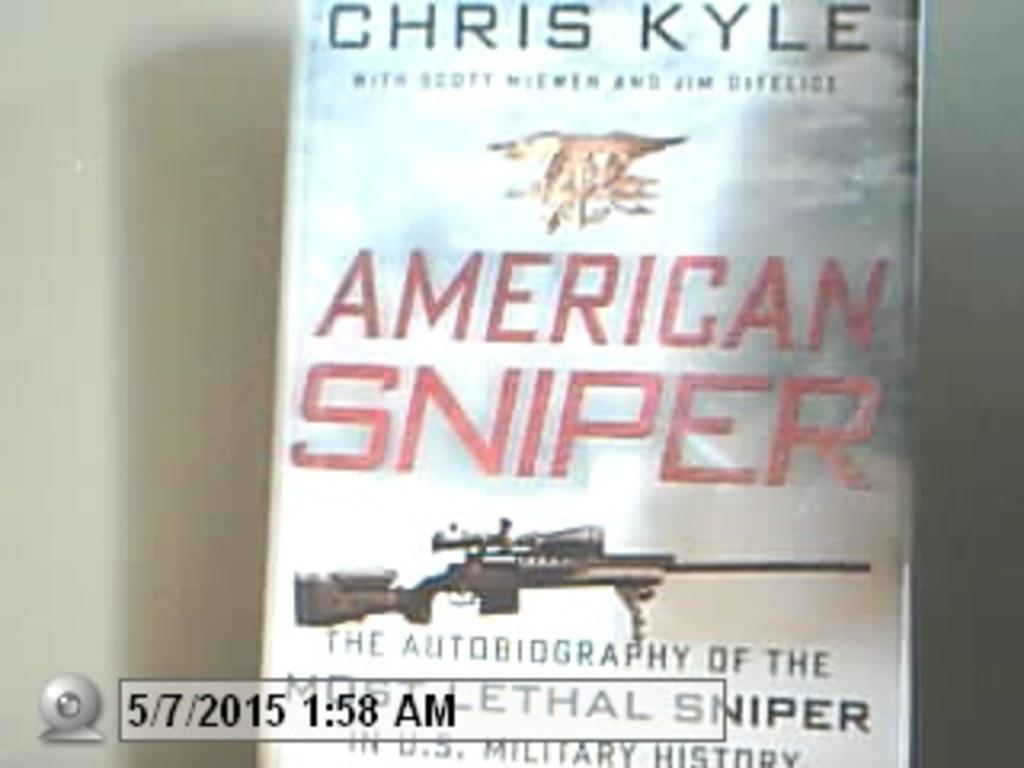What object is present in the image? There is a book in the image. What is depicted on the book? The book has a picture of a gun. Is there any text on the book? Yes, there is text on the book. Where is the robin perched in the image? There is no robin present in the image. What type of body is shown in the image? The image does not depict a body; it features a book with a picture of a gun and text. 